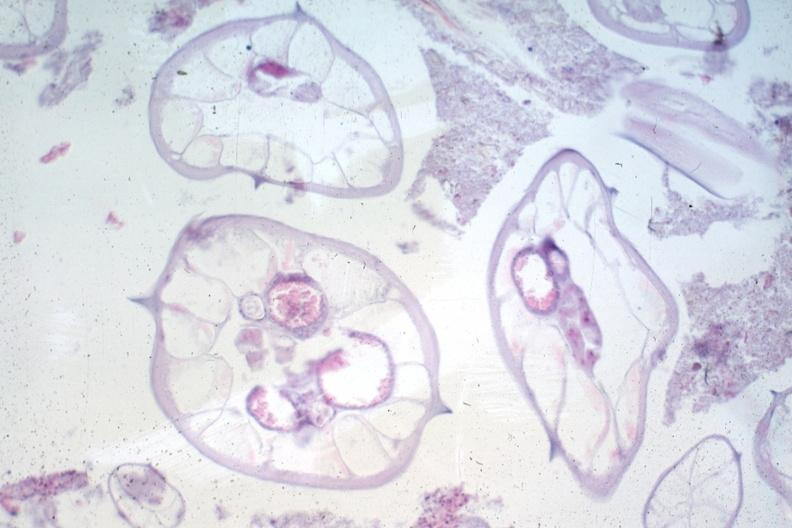does silver show worms no appendix structures?
Answer the question using a single word or phrase. No 